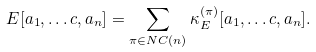Convert formula to latex. <formula><loc_0><loc_0><loc_500><loc_500>E [ a _ { 1 } , \dots c , a _ { n } ] = \sum _ { \pi \in N C ( n ) } \kappa _ { E } ^ { ( \pi ) } [ a _ { 1 } , \dots c , a _ { n } ] .</formula> 